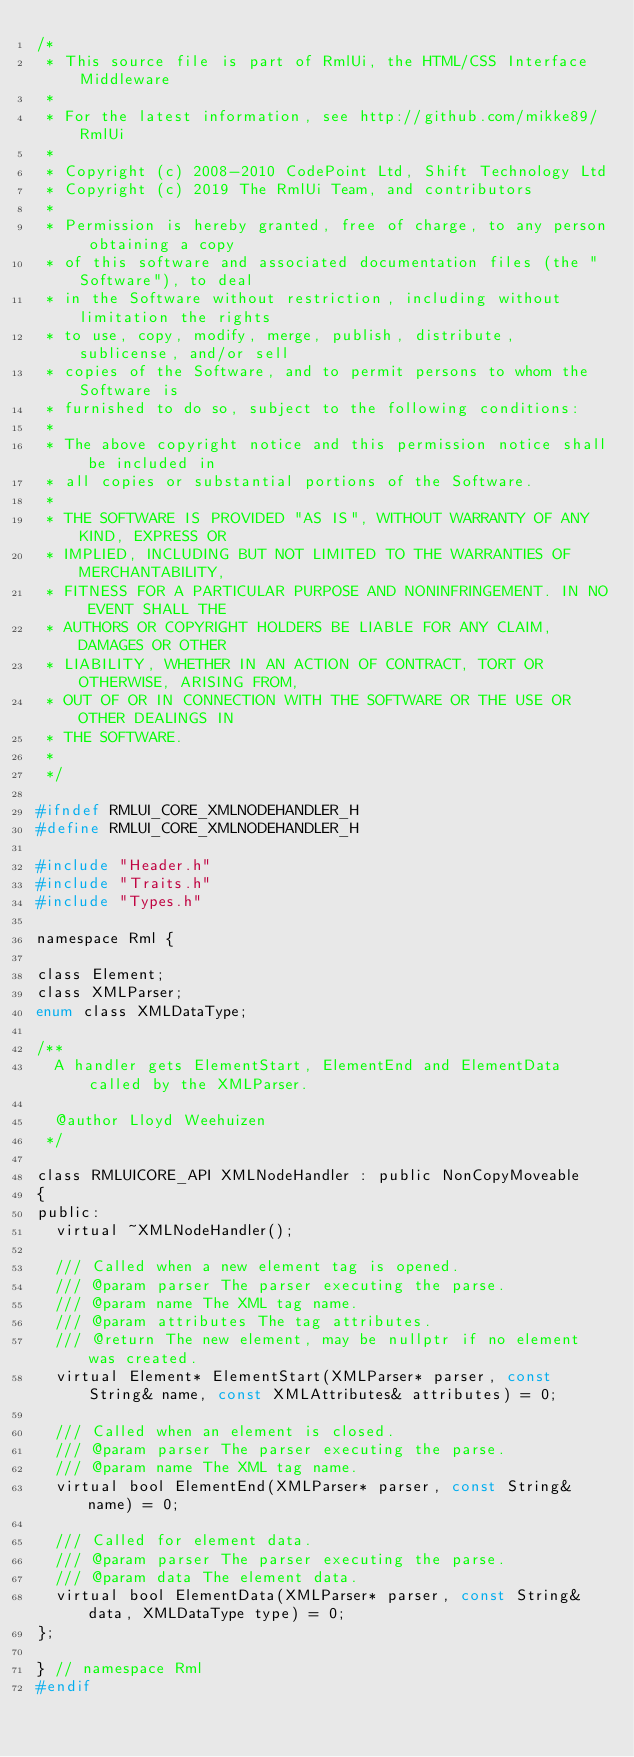Convert code to text. <code><loc_0><loc_0><loc_500><loc_500><_C_>/*
 * This source file is part of RmlUi, the HTML/CSS Interface Middleware
 *
 * For the latest information, see http://github.com/mikke89/RmlUi
 *
 * Copyright (c) 2008-2010 CodePoint Ltd, Shift Technology Ltd
 * Copyright (c) 2019 The RmlUi Team, and contributors
 *
 * Permission is hereby granted, free of charge, to any person obtaining a copy
 * of this software and associated documentation files (the "Software"), to deal
 * in the Software without restriction, including without limitation the rights
 * to use, copy, modify, merge, publish, distribute, sublicense, and/or sell
 * copies of the Software, and to permit persons to whom the Software is
 * furnished to do so, subject to the following conditions:
 *
 * The above copyright notice and this permission notice shall be included in
 * all copies or substantial portions of the Software.
 * 
 * THE SOFTWARE IS PROVIDED "AS IS", WITHOUT WARRANTY OF ANY KIND, EXPRESS OR
 * IMPLIED, INCLUDING BUT NOT LIMITED TO THE WARRANTIES OF MERCHANTABILITY,
 * FITNESS FOR A PARTICULAR PURPOSE AND NONINFRINGEMENT. IN NO EVENT SHALL THE
 * AUTHORS OR COPYRIGHT HOLDERS BE LIABLE FOR ANY CLAIM, DAMAGES OR OTHER
 * LIABILITY, WHETHER IN AN ACTION OF CONTRACT, TORT OR OTHERWISE, ARISING FROM,
 * OUT OF OR IN CONNECTION WITH THE SOFTWARE OR THE USE OR OTHER DEALINGS IN
 * THE SOFTWARE.
 *
 */

#ifndef RMLUI_CORE_XMLNODEHANDLER_H
#define RMLUI_CORE_XMLNODEHANDLER_H

#include "Header.h"
#include "Traits.h"
#include "Types.h"

namespace Rml {

class Element;
class XMLParser;
enum class XMLDataType;

/**
	A handler gets ElementStart, ElementEnd and ElementData called by the XMLParser.

	@author Lloyd Weehuizen
 */

class RMLUICORE_API XMLNodeHandler : public NonCopyMoveable
{
public:
	virtual ~XMLNodeHandler();

	/// Called when a new element tag is opened.
	/// @param parser The parser executing the parse.
	/// @param name The XML tag name.
	/// @param attributes The tag attributes.
	/// @return The new element, may be nullptr if no element was created.
	virtual Element* ElementStart(XMLParser* parser, const String& name, const XMLAttributes& attributes) = 0;

	/// Called when an element is closed.
	/// @param parser The parser executing the parse.
	/// @param name The XML tag name.
	virtual bool ElementEnd(XMLParser* parser, const String& name) = 0;

	/// Called for element data.
	/// @param parser The parser executing the parse.
	/// @param data The element data.
	virtual bool ElementData(XMLParser* parser, const String& data, XMLDataType type) = 0;
};

} // namespace Rml
#endif
</code> 